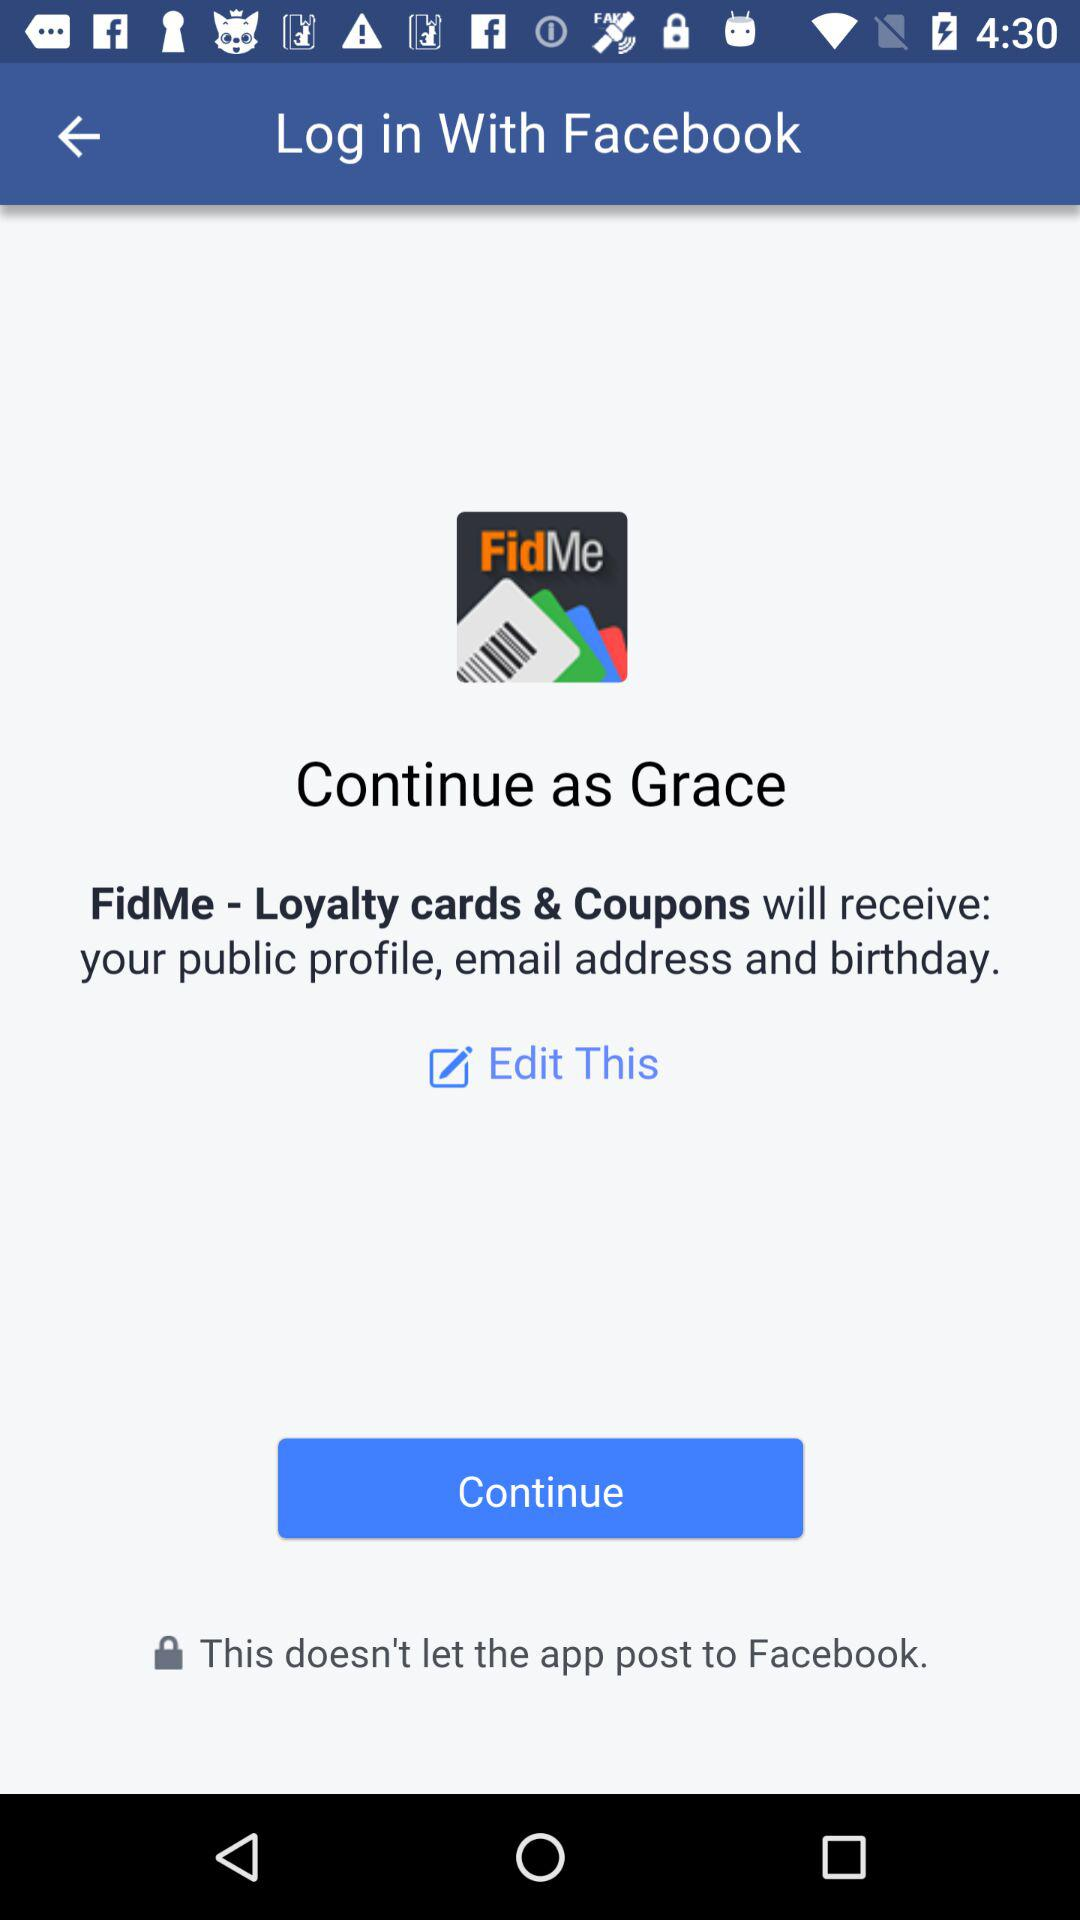Who will receive the public profile? The application "FidMe - Loyalty cards & Coupons" will receive the public profile. 